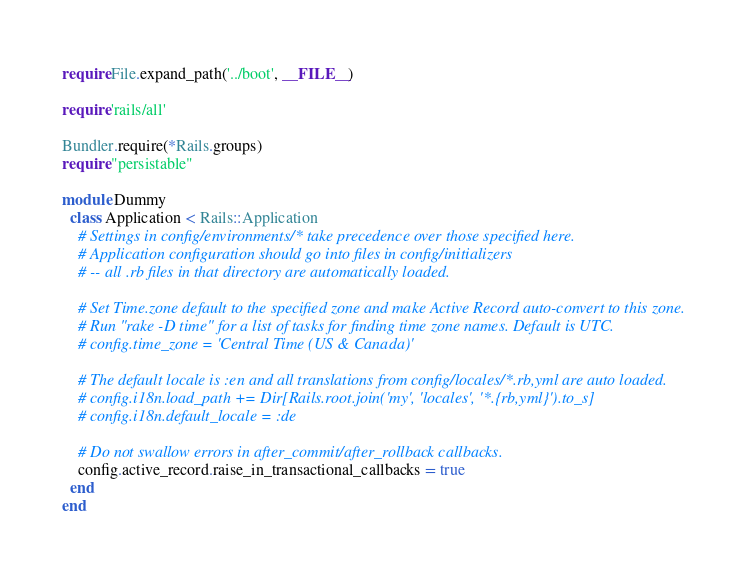<code> <loc_0><loc_0><loc_500><loc_500><_Ruby_>require File.expand_path('../boot', __FILE__)

require 'rails/all'

Bundler.require(*Rails.groups)
require "persistable"

module Dummy
  class Application < Rails::Application
    # Settings in config/environments/* take precedence over those specified here.
    # Application configuration should go into files in config/initializers
    # -- all .rb files in that directory are automatically loaded.

    # Set Time.zone default to the specified zone and make Active Record auto-convert to this zone.
    # Run "rake -D time" for a list of tasks for finding time zone names. Default is UTC.
    # config.time_zone = 'Central Time (US & Canada)'

    # The default locale is :en and all translations from config/locales/*.rb,yml are auto loaded.
    # config.i18n.load_path += Dir[Rails.root.join('my', 'locales', '*.{rb,yml}').to_s]
    # config.i18n.default_locale = :de

    # Do not swallow errors in after_commit/after_rollback callbacks.
    config.active_record.raise_in_transactional_callbacks = true
  end
end

</code> 